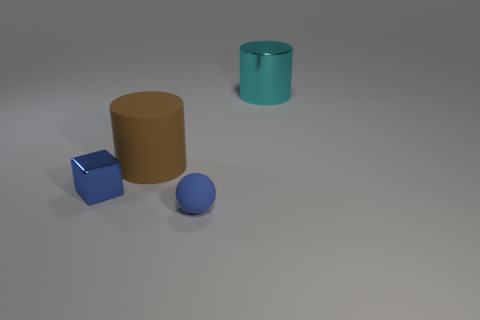Add 4 small rubber objects. How many objects exist? 8 Subtract all balls. How many objects are left? 3 Subtract all tiny shiny things. Subtract all purple metallic things. How many objects are left? 3 Add 4 big cylinders. How many big cylinders are left? 6 Add 1 big purple matte things. How many big purple matte things exist? 1 Subtract 0 brown cubes. How many objects are left? 4 